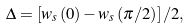Convert formula to latex. <formula><loc_0><loc_0><loc_500><loc_500>\Delta = \left [ w _ { s } \left ( 0 \right ) - w _ { s } \left ( \pi / 2 \right ) \right ] / 2 ,</formula> 